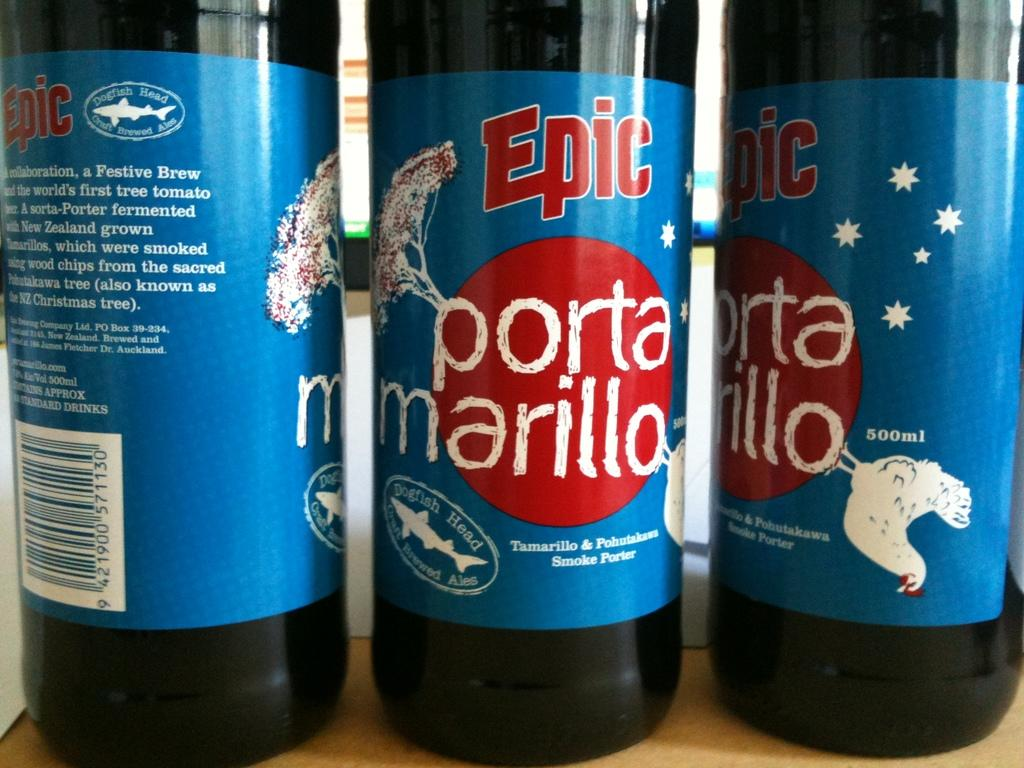How many bottles are visible in the image? There are three bottles in the image. What is the color of the surface on which the bottles are placed? The bottles are on a cream-colored surface. What decorations are on the bottles? There are stickers on the bottles. What color are the stickers on the bottles? The stickers are blue in color. Can you see any silk fabric in the image? There is no silk fabric present in the image. What type of vegetable is growing in the ocean near the bottles? There is no ocean or vegetable present in the image; it only features three bottles with blue stickers on a cream-colored surface. 